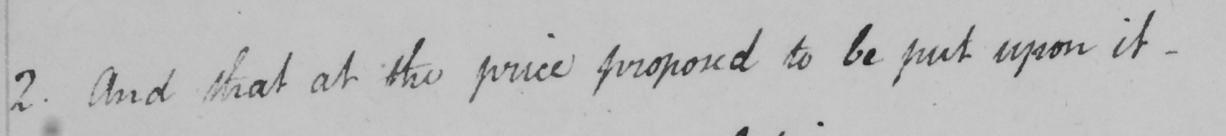Please provide the text content of this handwritten line. 2 . And that at the price proposed to be put upon it . 